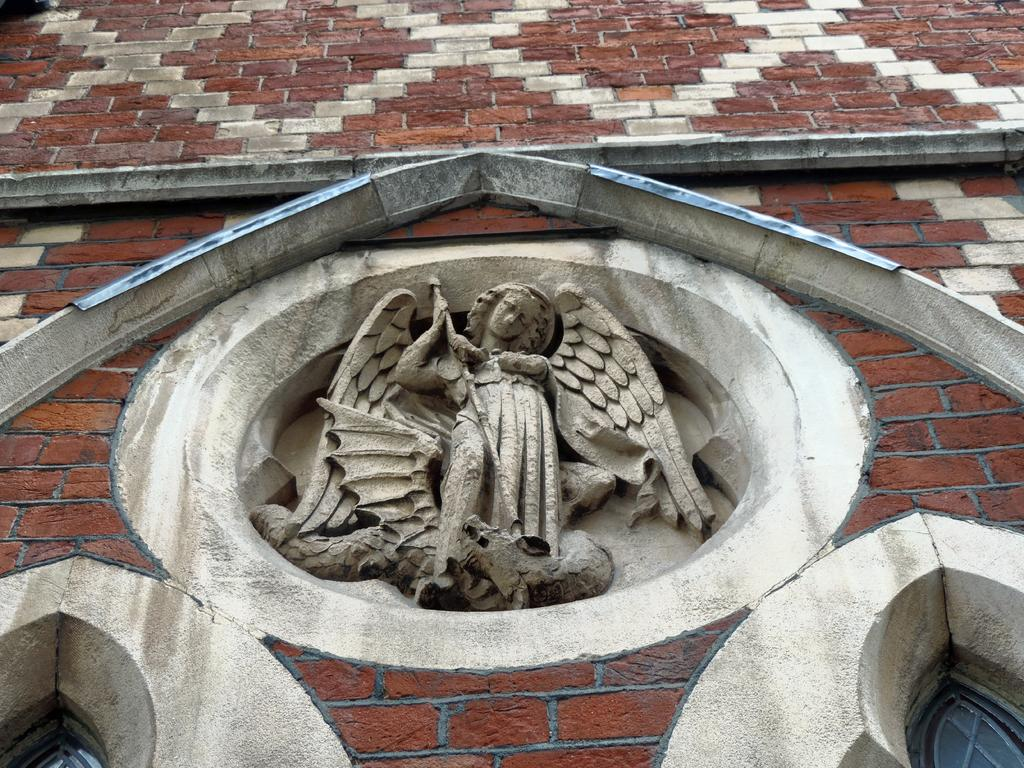What is the main subject in the image? There is a statue in the image. Where is the statue located? The statue is in the middle of a brick wall. Are there any other features on the wall surrounding the statue? Yes, there are two windows below the statue on either side. How many horses can be seen in the image? There are no horses present in the image; it features a statue on a brick wall with two windows below it. 